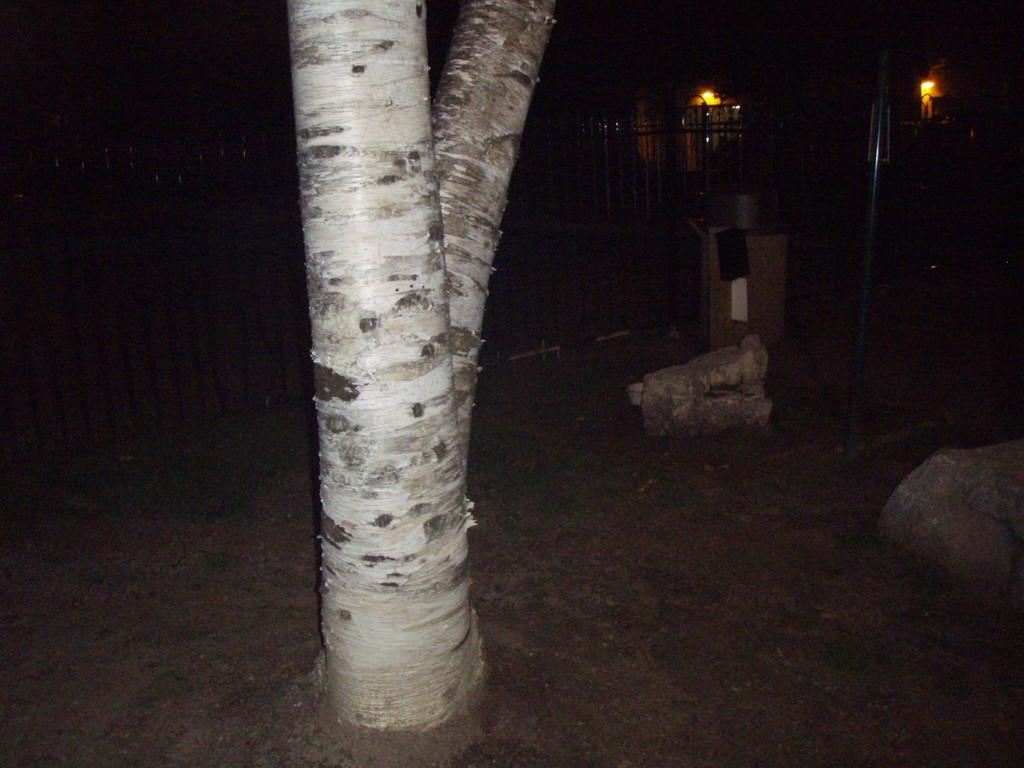What type of natural element is present in the image? There is a branch in the image. What type of geological formation can be seen in the image? There are rocks in the image. What type of man-made structure is present in the image? There is a pole in the image. What type of barrier is present in the image? There is a fencing in the image. What is the color of the background in the image? The background of the image is black in color. Can you tell me how many firemen are depicted in the image? There are no firemen present in the image. What is the direction of the current in the image? There is no reference to a current in the image. 